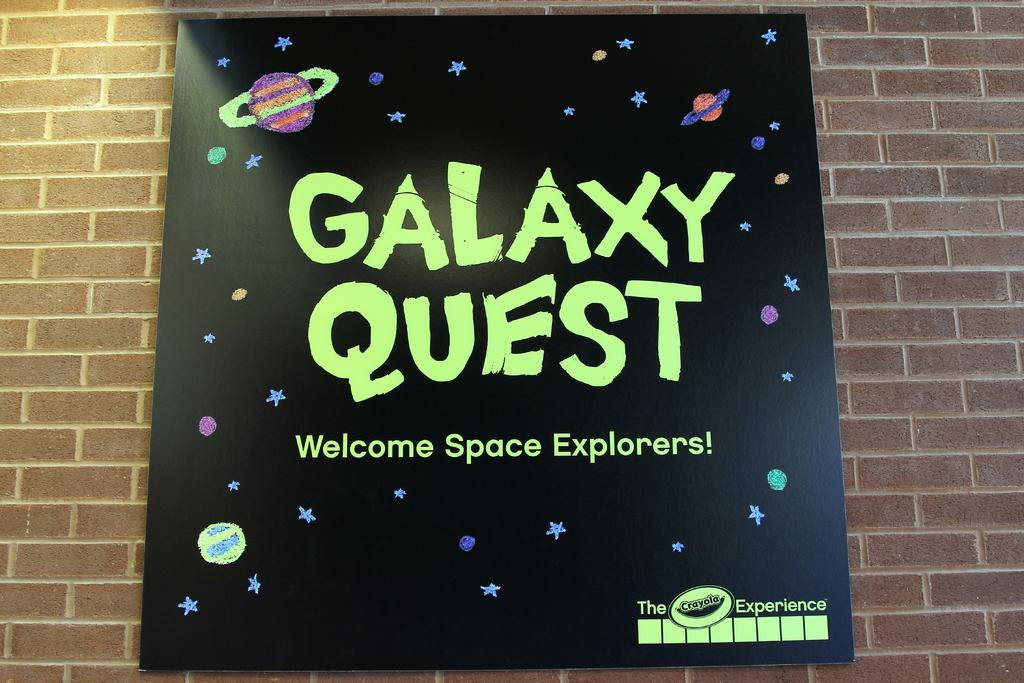<image>
Write a terse but informative summary of the picture. A poster that reads Galaxy Quest on a brick wall. 